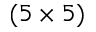<formula> <loc_0><loc_0><loc_500><loc_500>( 5 \times 5 )</formula> 